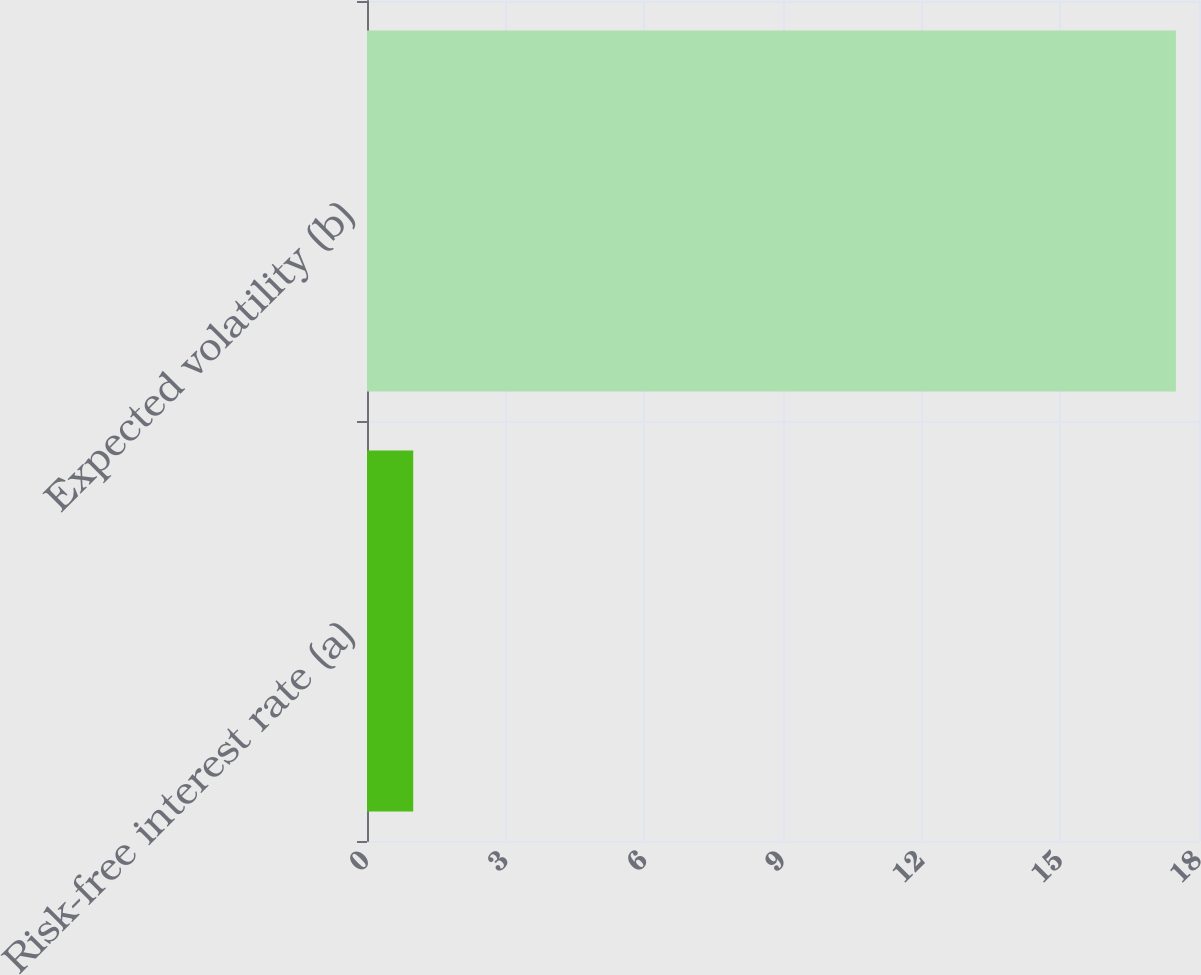Convert chart. <chart><loc_0><loc_0><loc_500><loc_500><bar_chart><fcel>Risk-free interest rate (a)<fcel>Expected volatility (b)<nl><fcel>1<fcel>17.5<nl></chart> 